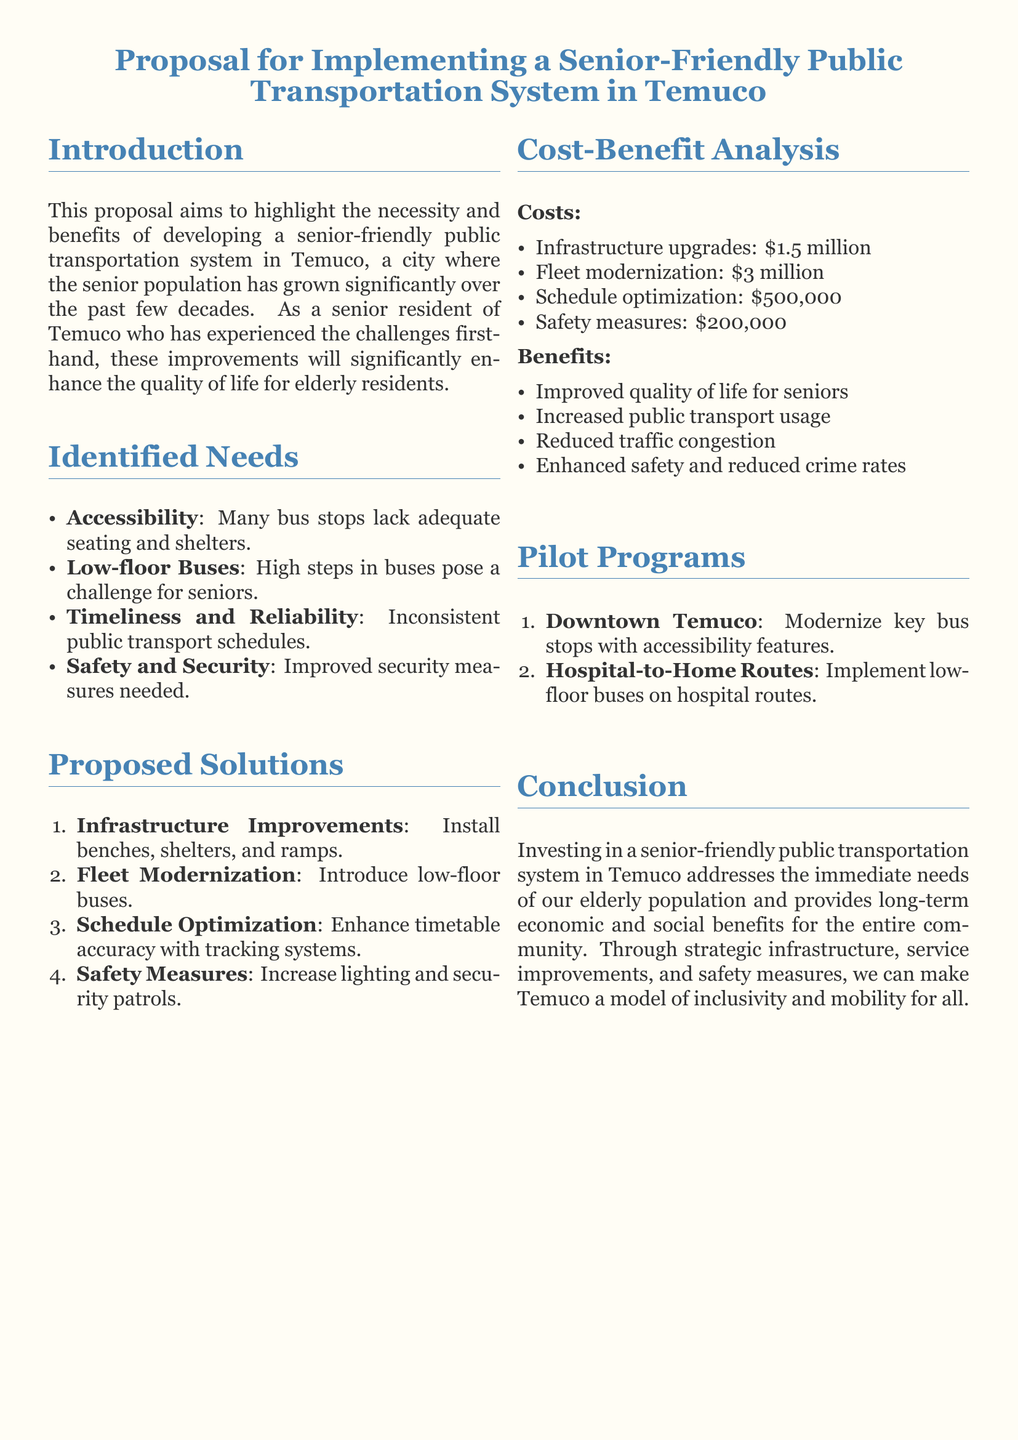What is the total cost of infrastructure upgrades? The total cost of infrastructure upgrades is mentioned in the cost-benefit analysis section as $1.5 million.
Answer: $1.5 million What is one identified need for seniors in Temuco? The identified needs section lists several specific needs, one of which is accessibility in public transportation.
Answer: Accessibility How many pilot programs are proposed? The document outlines two pilot programs in the pilot programs section.
Answer: Two What is the cost of safety measures? The safety measures cost is outlined in the cost-benefit analysis section, which states it is $200,000.
Answer: $200,000 What type of buses is proposed for modernization? The fleet modernization section highlights the introduction of low-floor buses as a specific improvement.
Answer: Low-floor buses What is one benefit of the proposed transportation system? The benefits section includes improved quality of life for seniors as one benefit of the proposed system.
Answer: Improved quality of life for seniors What are the proposed improvements for infrastructure? Infrastructure improvements listed include installing benches, shelters, and ramps for better accessibility.
Answer: Install benches, shelters, and ramps What city is the focus of the proposal? The introduction specifies that the proposal is focused on the city of Temuco.
Answer: Temuco 